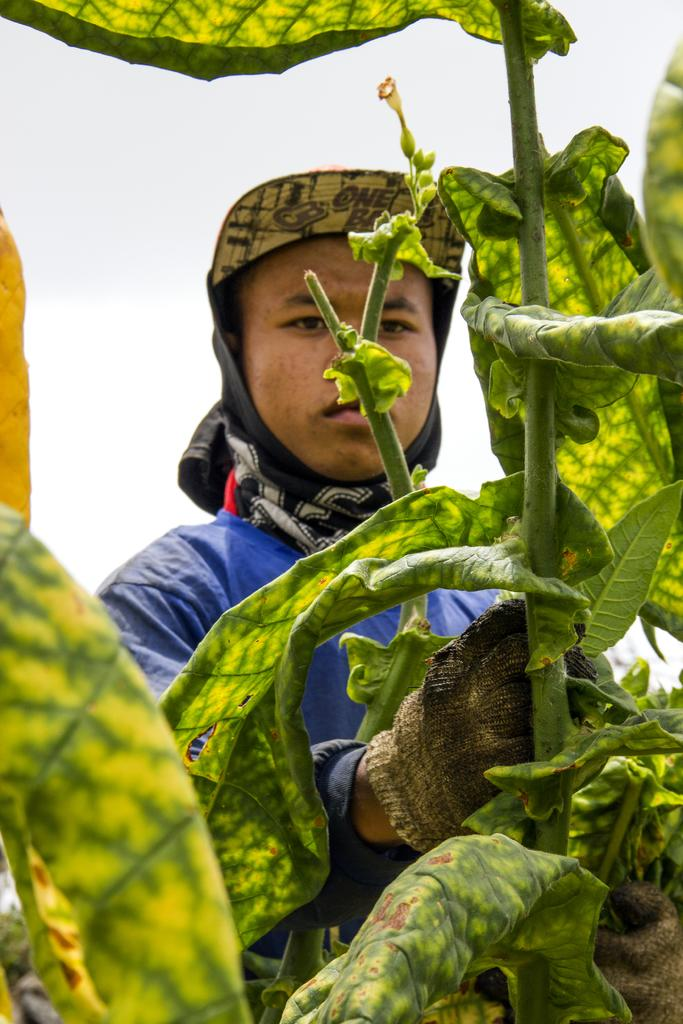Who is in the image? There is a man in the image. What is the man wearing? The man is wearing a blue jacket. What is the man's location in relation to the plants? The man is near plants. What type of vegetation is visible at the bottom of the image? Leaves are visible at the bottom of the image. What can be seen in the sky in the image? There is sky visible in the image, and clouds are present in the sky. What type of celery is the man eating in the image? There is no celery present in the image, and the man is not eating anything. What room is the man in, and what furniture can be seen in the room? The image does not show a room, and no furniture is visible. 